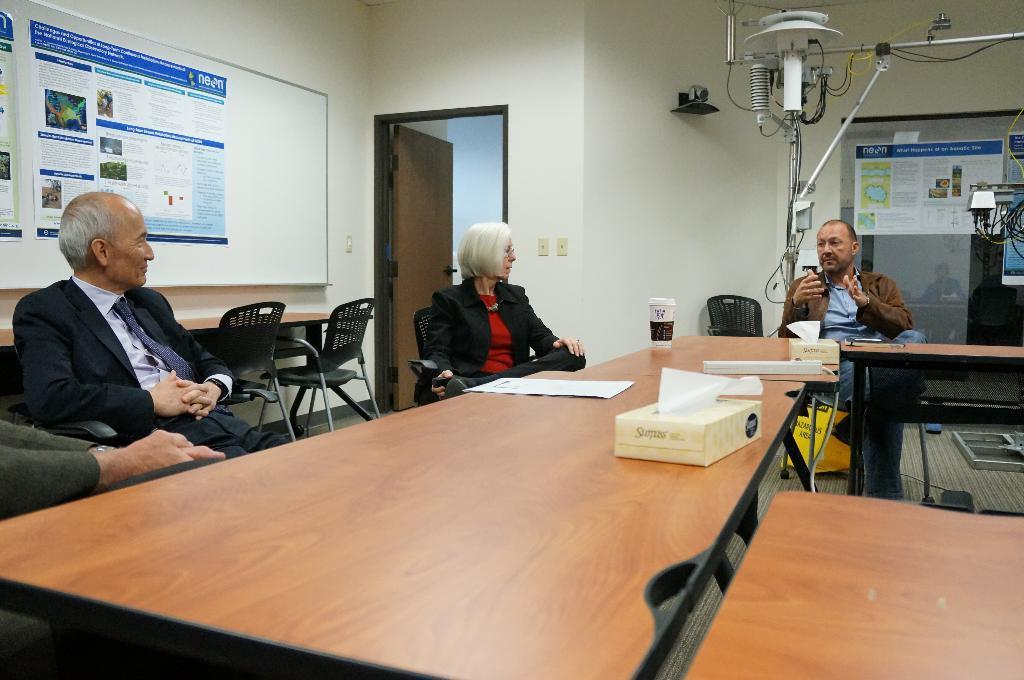Can you describe this image briefly? As we can see in the image, there is a board, door, wall, three people sitting on chairs and a table. 